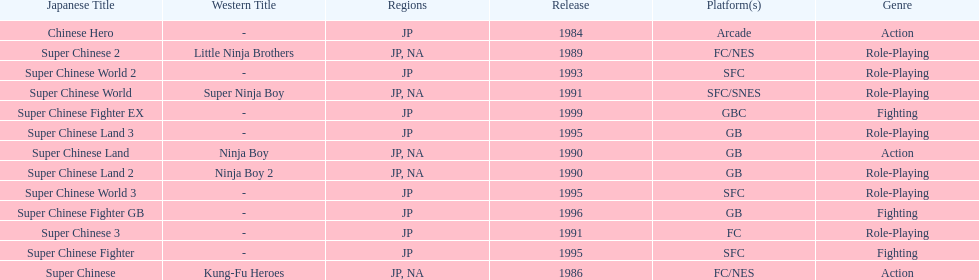How many action games were released in north america? 2. 